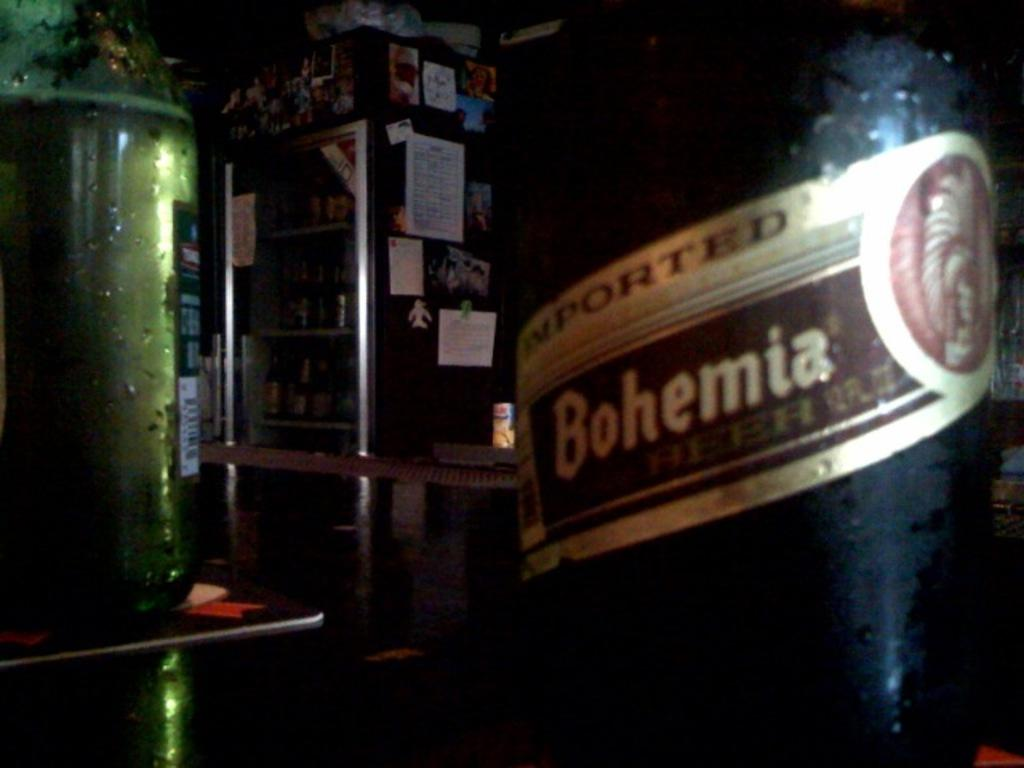Provide a one-sentence caption for the provided image. Dark bottle of Imported Bohemia inside a dark room. 